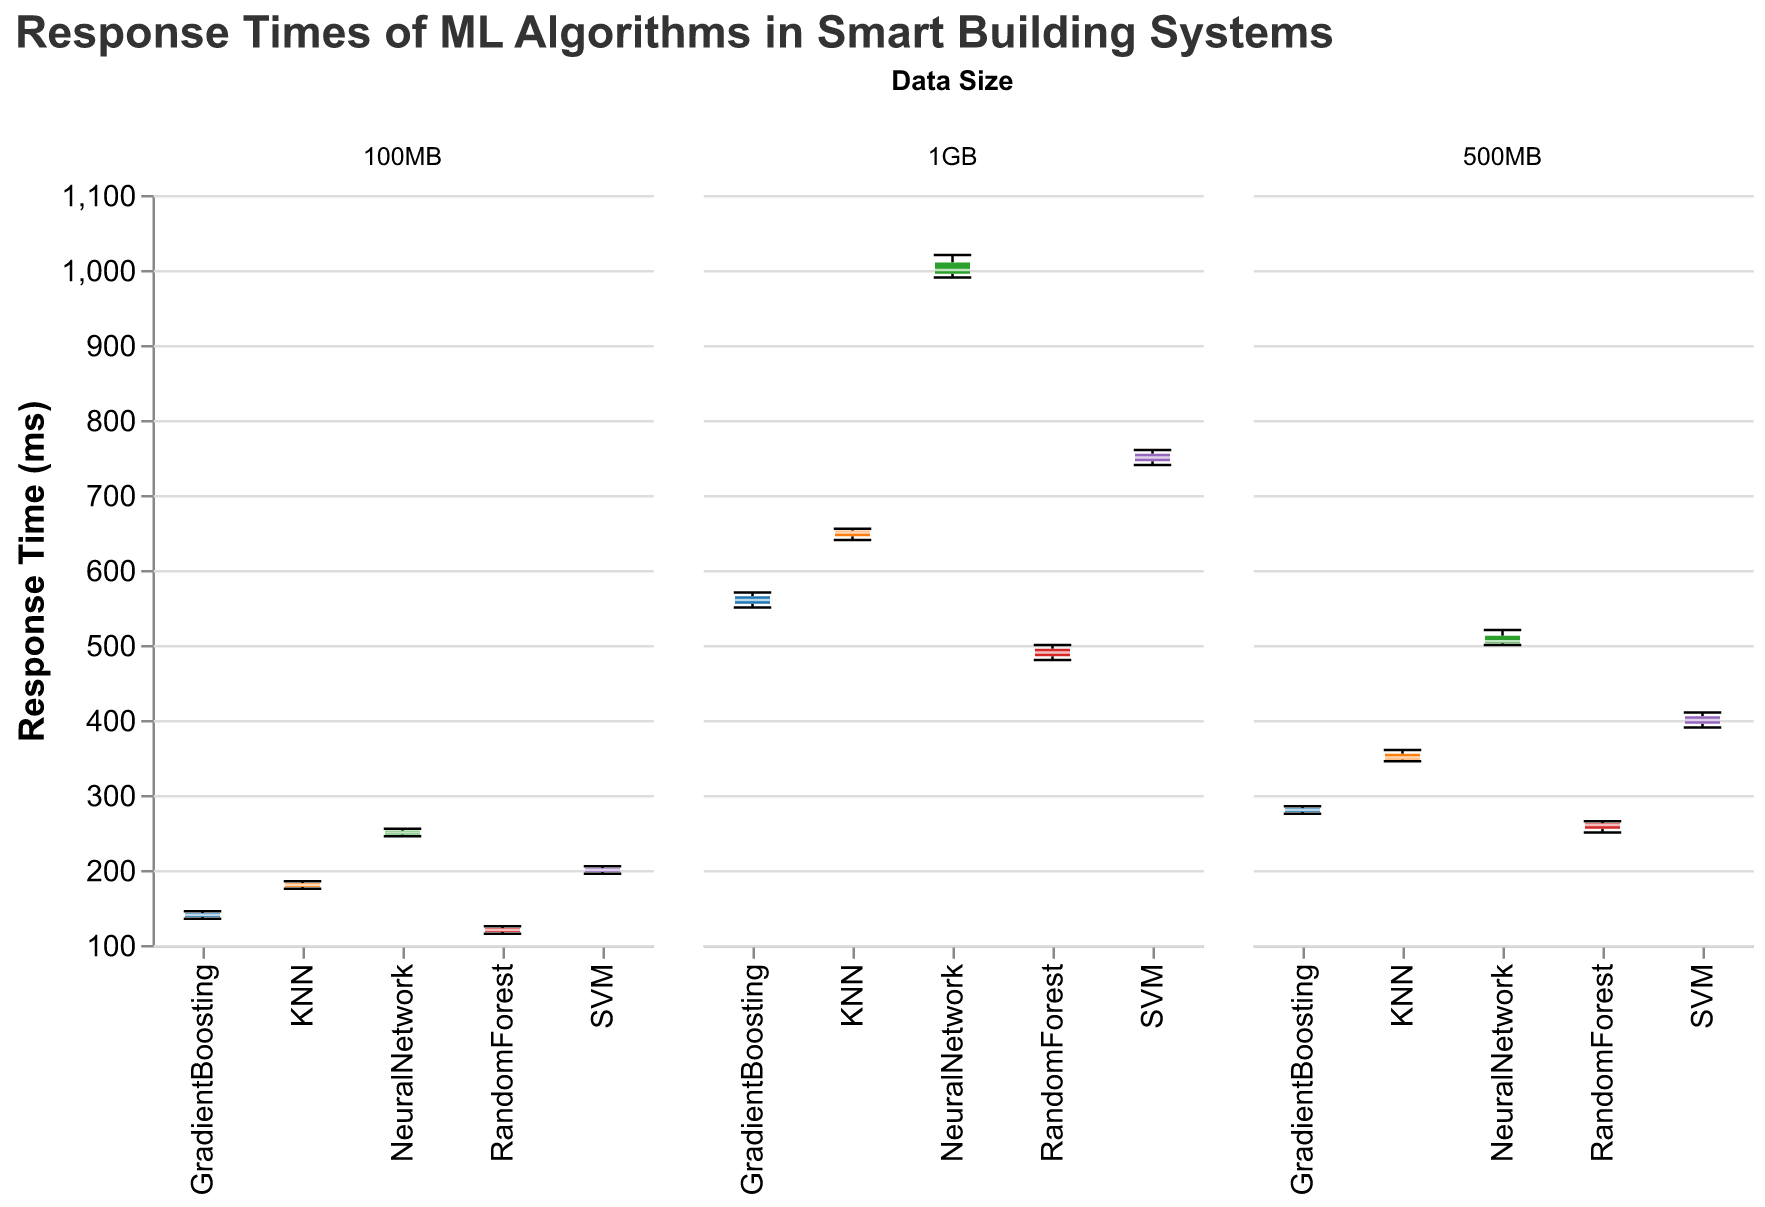What is the title of the plot? The title of the plot is located at the top of the figure and it describes the content and purpose of the figure. The title reads "Response Times of ML Algorithms in Smart Building Systems".
Answer: Response Times of ML Algorithms in Smart Building Systems How many algorithm types are compared in the figure? The figure contains multiple subplots with box plots. Each subplot compares the response times of different algorithms for each data size category. By counting the unique algorithms in the legend or color scheme, we can see there are five algorithms: RandomForest, SVM, KNN, GradientBoosting, and NeuralNetwork.
Answer: 5 Which algorithm has the highest median response time for the 1GB data size? To find the highest median response time, look at the center line of each box plot for the 1GB data size category. The NeuralNetwork algorithm shows the highest median response time.
Answer: NeuralNetwork What is the range of response times for the RandomForest algorithm with 500MB data size? The range of response times can be observed by looking at the whiskers of the box plot for RandomForest in the 500MB subgroup. The minimum whisker is at 250 ms and the maximum whisker is at 265 ms. Therefore, the range is 265 - 250.
Answer: 15 ms Which algorithm shows the smallest variation in response times for the 100MB data size? Variation in response times can be seen by the interquartile range (IQR), which is the width of the box. For the 100MB data size, the GradientBoosting algorithm has the smallest box, indicating the smallest variation.
Answer: GradientBoosting How do the response times of SVM and NeuralNetwork algorithms compare for the 500MB data size? To compare, look at the box plots for both algorithms in the 500MB subgroup. The NeuralNetwork median line is higher than the SVM's, indicating that NeuralNetwork generally has higher response times. The upper whisker of SVM is lower than the lower whisker of NeuralNetwork, indicating NeuralNetwork has overall higher response times.
Answer: NeuralNetwork has higher response times than SVM What is the median response time of the KNN algorithm for the 100MB data size? The median response time can be found by looking at the middle line in the KNN box plot for the 100MB data size. Here, the median line is at 180 ms.
Answer: 180 ms Which algorithm has the largest variation in response time for the 1GB data size? The largest variation in response time can be identified by the width of the box and the length of the whiskers. For the 1GB data size, the NeuralNetwork algorithm shows the largest variation as its whiskers extend from about 990 ms to 1020 ms.
Answer: NeuralNetwork 